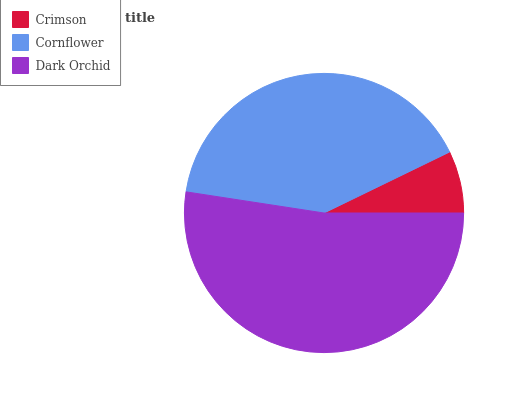Is Crimson the minimum?
Answer yes or no. Yes. Is Dark Orchid the maximum?
Answer yes or no. Yes. Is Cornflower the minimum?
Answer yes or no. No. Is Cornflower the maximum?
Answer yes or no. No. Is Cornflower greater than Crimson?
Answer yes or no. Yes. Is Crimson less than Cornflower?
Answer yes or no. Yes. Is Crimson greater than Cornflower?
Answer yes or no. No. Is Cornflower less than Crimson?
Answer yes or no. No. Is Cornflower the high median?
Answer yes or no. Yes. Is Cornflower the low median?
Answer yes or no. Yes. Is Dark Orchid the high median?
Answer yes or no. No. Is Dark Orchid the low median?
Answer yes or no. No. 